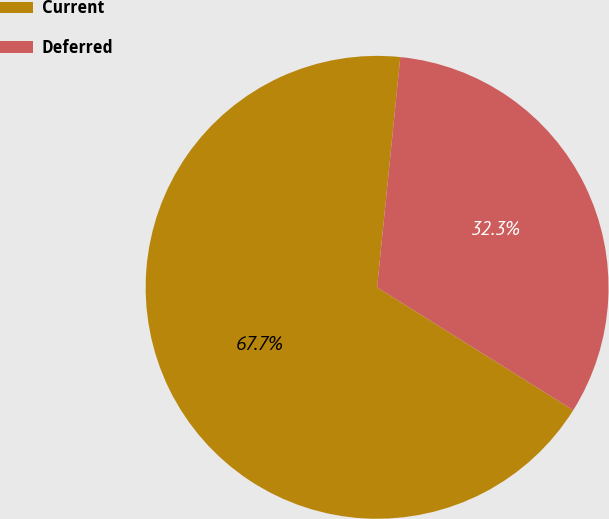Convert chart to OTSL. <chart><loc_0><loc_0><loc_500><loc_500><pie_chart><fcel>Current<fcel>Deferred<nl><fcel>67.69%<fcel>32.31%<nl></chart> 